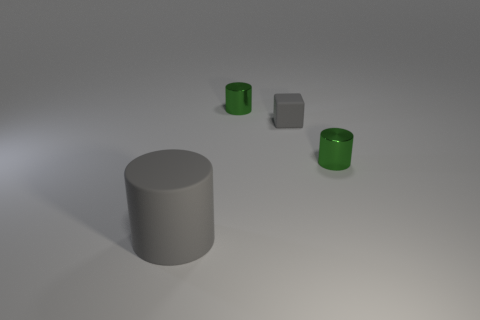Subtract all metallic cylinders. How many cylinders are left? 1 Add 3 tiny cylinders. How many objects exist? 7 Subtract all cubes. How many objects are left? 3 Subtract all yellow blocks. How many green cylinders are left? 2 Subtract all cyan cylinders. Subtract all yellow blocks. How many cylinders are left? 3 Subtract all matte blocks. Subtract all metal cylinders. How many objects are left? 1 Add 3 large gray matte objects. How many large gray matte objects are left? 4 Add 3 tiny green things. How many tiny green things exist? 5 Subtract all gray cylinders. How many cylinders are left? 2 Subtract 0 yellow balls. How many objects are left? 4 